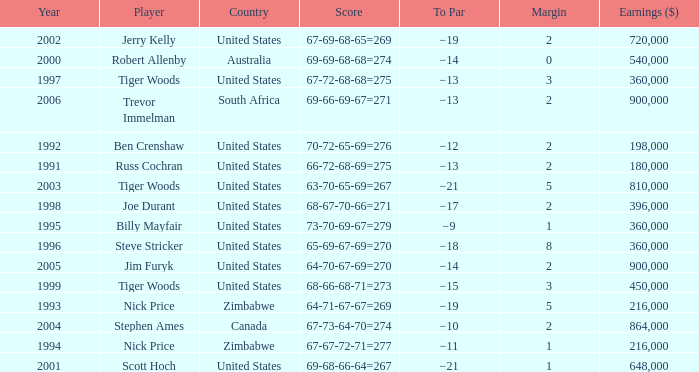What is russ cochran's average margin? 2.0. 